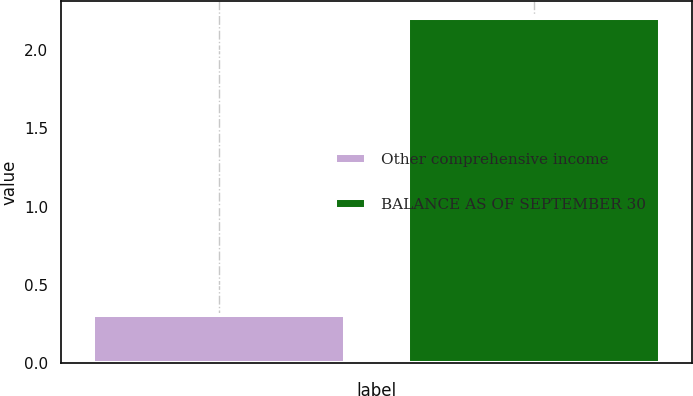Convert chart to OTSL. <chart><loc_0><loc_0><loc_500><loc_500><bar_chart><fcel>Other comprehensive income<fcel>BALANCE AS OF SEPTEMBER 30<nl><fcel>0.31<fcel>2.2<nl></chart> 